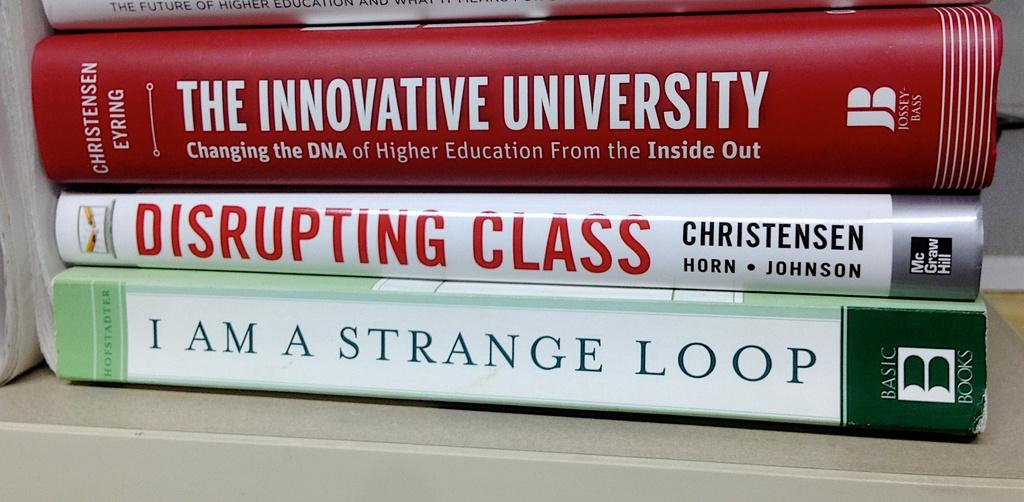<image>
Share a concise interpretation of the image provided. Books are stacked on top of each other including the title Disrupting Class. 